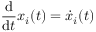<formula> <loc_0><loc_0><loc_500><loc_500>\frac { \mathrm d } { \mathrm d t } x _ { i } ( t ) = \dot { x } _ { i } ( t )</formula> 